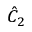<formula> <loc_0><loc_0><loc_500><loc_500>{ \hat { C } } _ { 2 }</formula> 